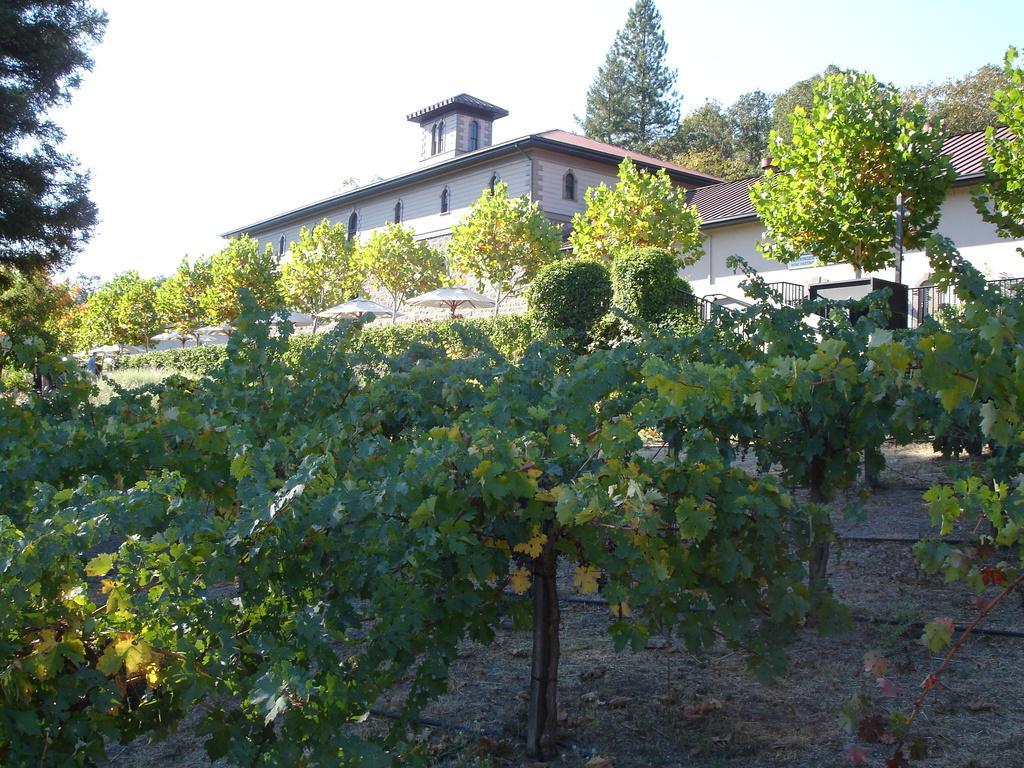In one or two sentences, can you explain what this image depicts? In this picture we can see there are plants, trees, umbrellas, iron grilles, a pole, wall, houses and the sky. 